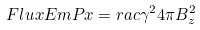<formula> <loc_0><loc_0><loc_500><loc_500>\ F l u x E m P x = r a c { \gamma ^ { 2 } } { 4 \pi } B _ { z } ^ { 2 }</formula> 